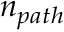Convert formula to latex. <formula><loc_0><loc_0><loc_500><loc_500>n _ { p a t h }</formula> 